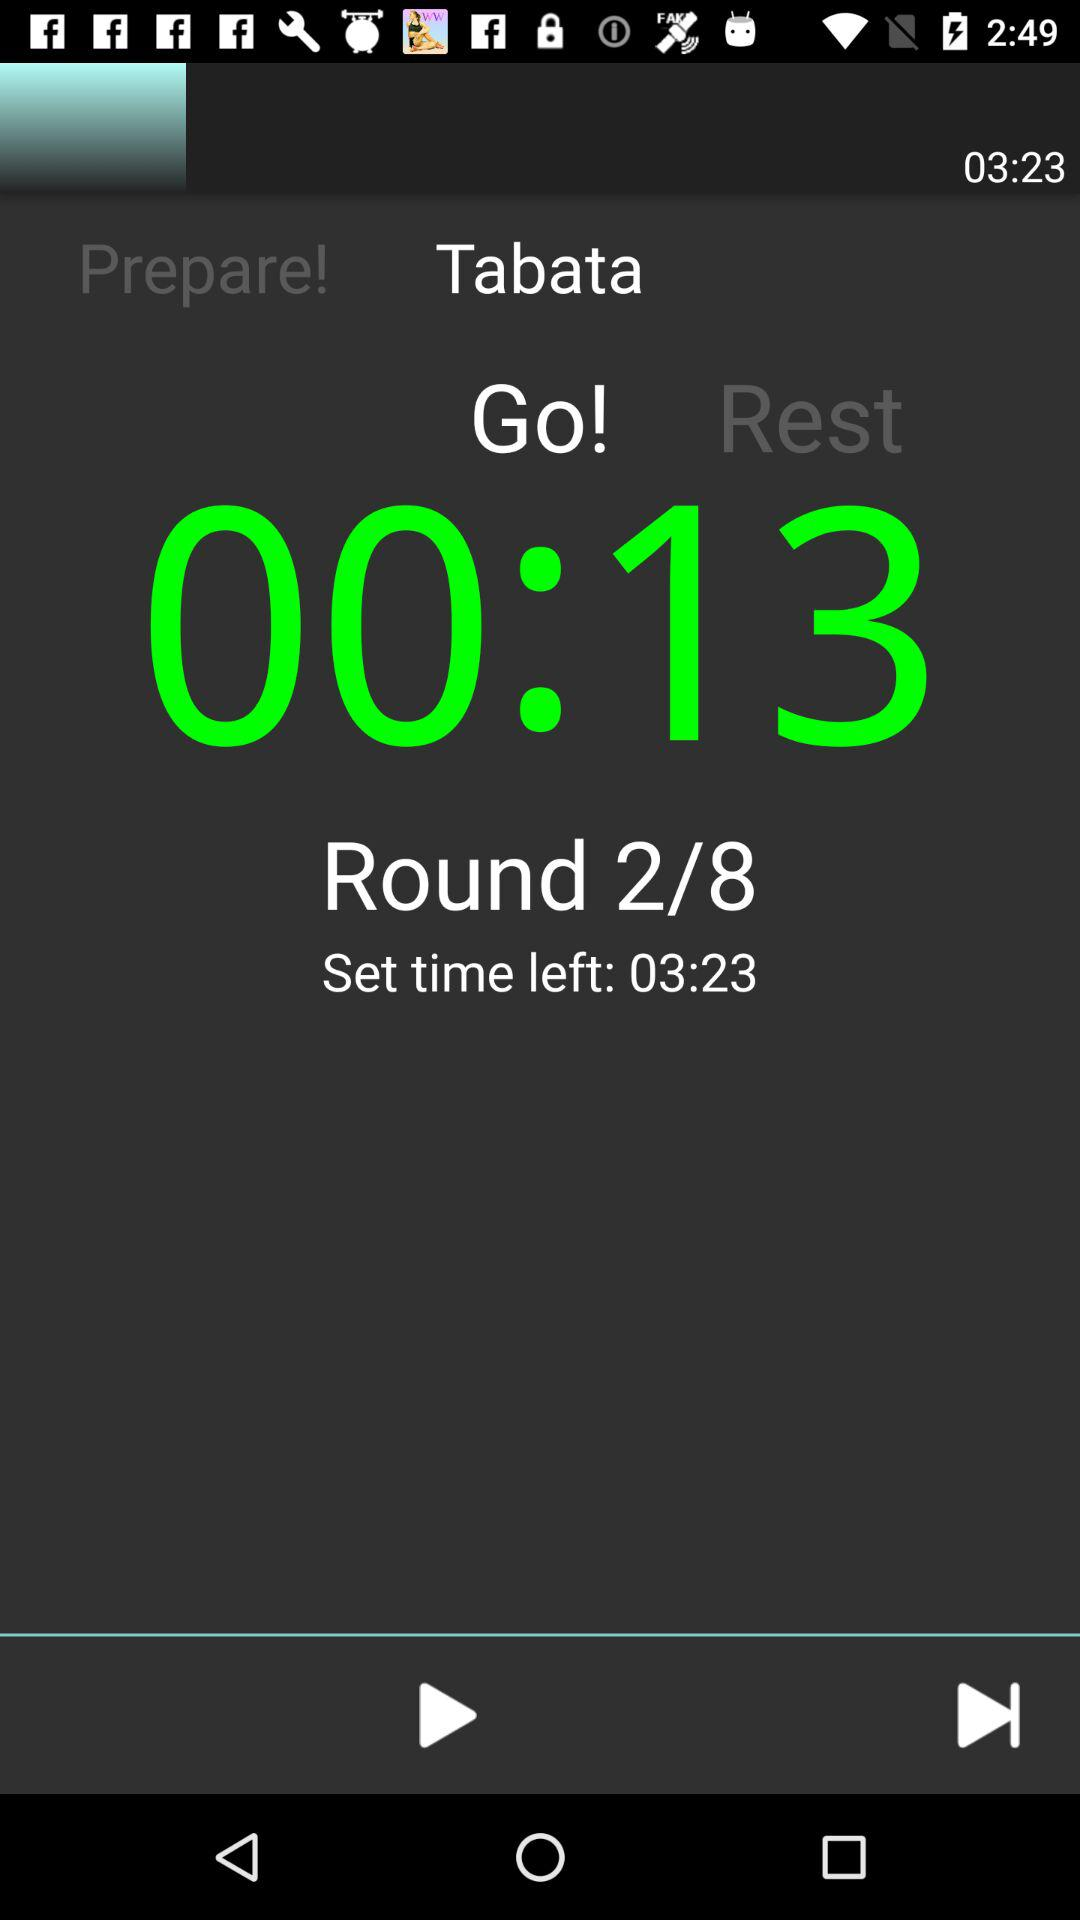In which round number am I? You are in round number 2. 